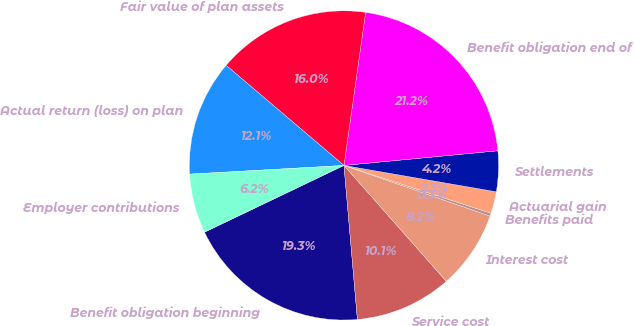<chart> <loc_0><loc_0><loc_500><loc_500><pie_chart><fcel>Benefit obligation beginning<fcel>Service cost<fcel>Interest cost<fcel>Benefits paid<fcel>Actuarial gain<fcel>Settlements<fcel>Benefit obligation end of<fcel>Fair value of plan assets<fcel>Actual return (loss) on plan<fcel>Employer contributions<nl><fcel>19.28%<fcel>10.13%<fcel>8.17%<fcel>0.31%<fcel>2.28%<fcel>4.24%<fcel>21.25%<fcel>16.03%<fcel>12.1%<fcel>6.21%<nl></chart> 